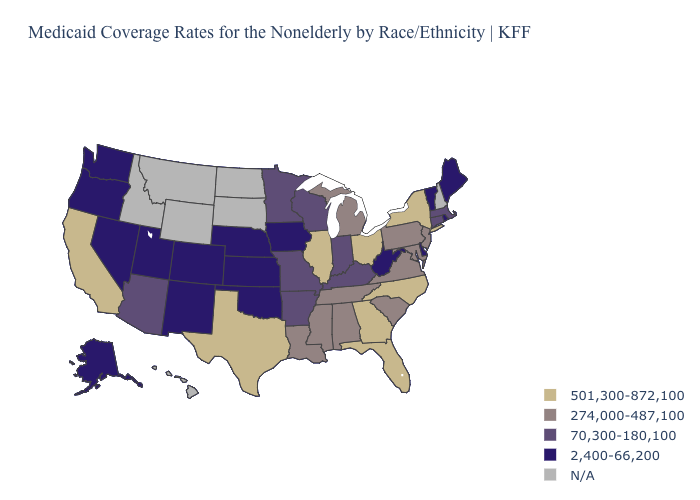What is the value of Oregon?
Be succinct. 2,400-66,200. Which states hav the highest value in the MidWest?
Keep it brief. Illinois, Ohio. What is the value of Montana?
Give a very brief answer. N/A. What is the lowest value in the South?
Short answer required. 2,400-66,200. What is the value of Tennessee?
Give a very brief answer. 274,000-487,100. Which states have the lowest value in the USA?
Answer briefly. Alaska, Colorado, Delaware, Iowa, Kansas, Maine, Nebraska, Nevada, New Mexico, Oklahoma, Oregon, Rhode Island, Utah, Vermont, Washington, West Virginia. Which states have the lowest value in the West?
Keep it brief. Alaska, Colorado, Nevada, New Mexico, Oregon, Utah, Washington. What is the value of West Virginia?
Concise answer only. 2,400-66,200. Among the states that border North Carolina , does Virginia have the highest value?
Quick response, please. No. Name the states that have a value in the range 501,300-872,100?
Short answer required. California, Florida, Georgia, Illinois, New York, North Carolina, Ohio, Texas. Name the states that have a value in the range N/A?
Concise answer only. Hawaii, Idaho, Montana, New Hampshire, North Dakota, South Dakota, Wyoming. Does the map have missing data?
Give a very brief answer. Yes. Name the states that have a value in the range 2,400-66,200?
Answer briefly. Alaska, Colorado, Delaware, Iowa, Kansas, Maine, Nebraska, Nevada, New Mexico, Oklahoma, Oregon, Rhode Island, Utah, Vermont, Washington, West Virginia. Name the states that have a value in the range 2,400-66,200?
Be succinct. Alaska, Colorado, Delaware, Iowa, Kansas, Maine, Nebraska, Nevada, New Mexico, Oklahoma, Oregon, Rhode Island, Utah, Vermont, Washington, West Virginia. What is the lowest value in states that border Illinois?
Concise answer only. 2,400-66,200. 